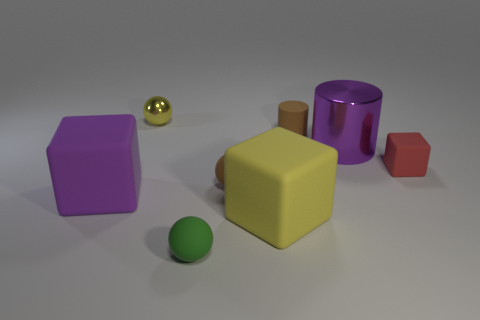Add 1 tiny metallic things. How many objects exist? 9 Subtract all spheres. How many objects are left? 5 Add 1 purple rubber cubes. How many purple rubber cubes exist? 2 Subtract 0 gray cubes. How many objects are left? 8 Subtract all tiny brown things. Subtract all yellow matte blocks. How many objects are left? 5 Add 4 green rubber objects. How many green rubber objects are left? 5 